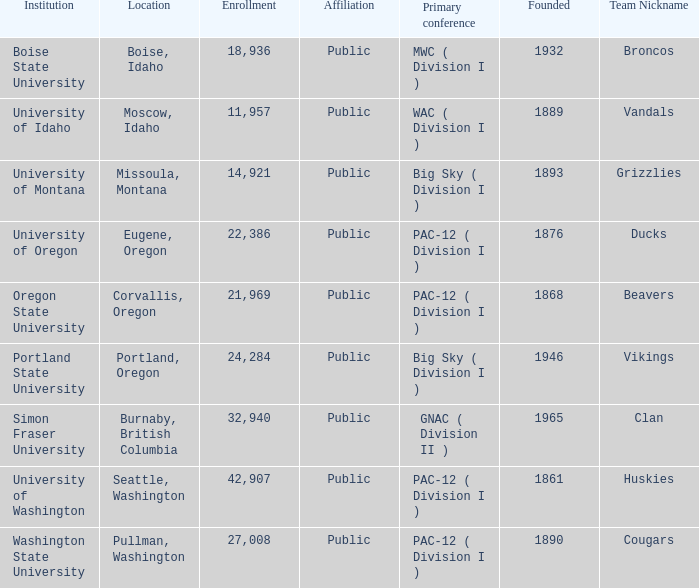What is the location of the team nicknamed Broncos, which was founded after 1889? Boise, Idaho. 